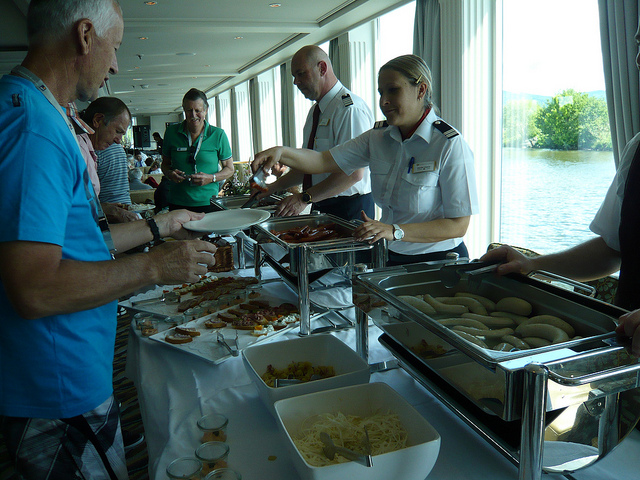<image>What room is shown? I am not sure which room is shown. It might be a dining room, kitchen, or a banquet room. What room is shown? I am not sure what room is shown. It can be seen as 'banquet room', 'kitchen', 'dining room', 'conference room' or 'dining hall'. 